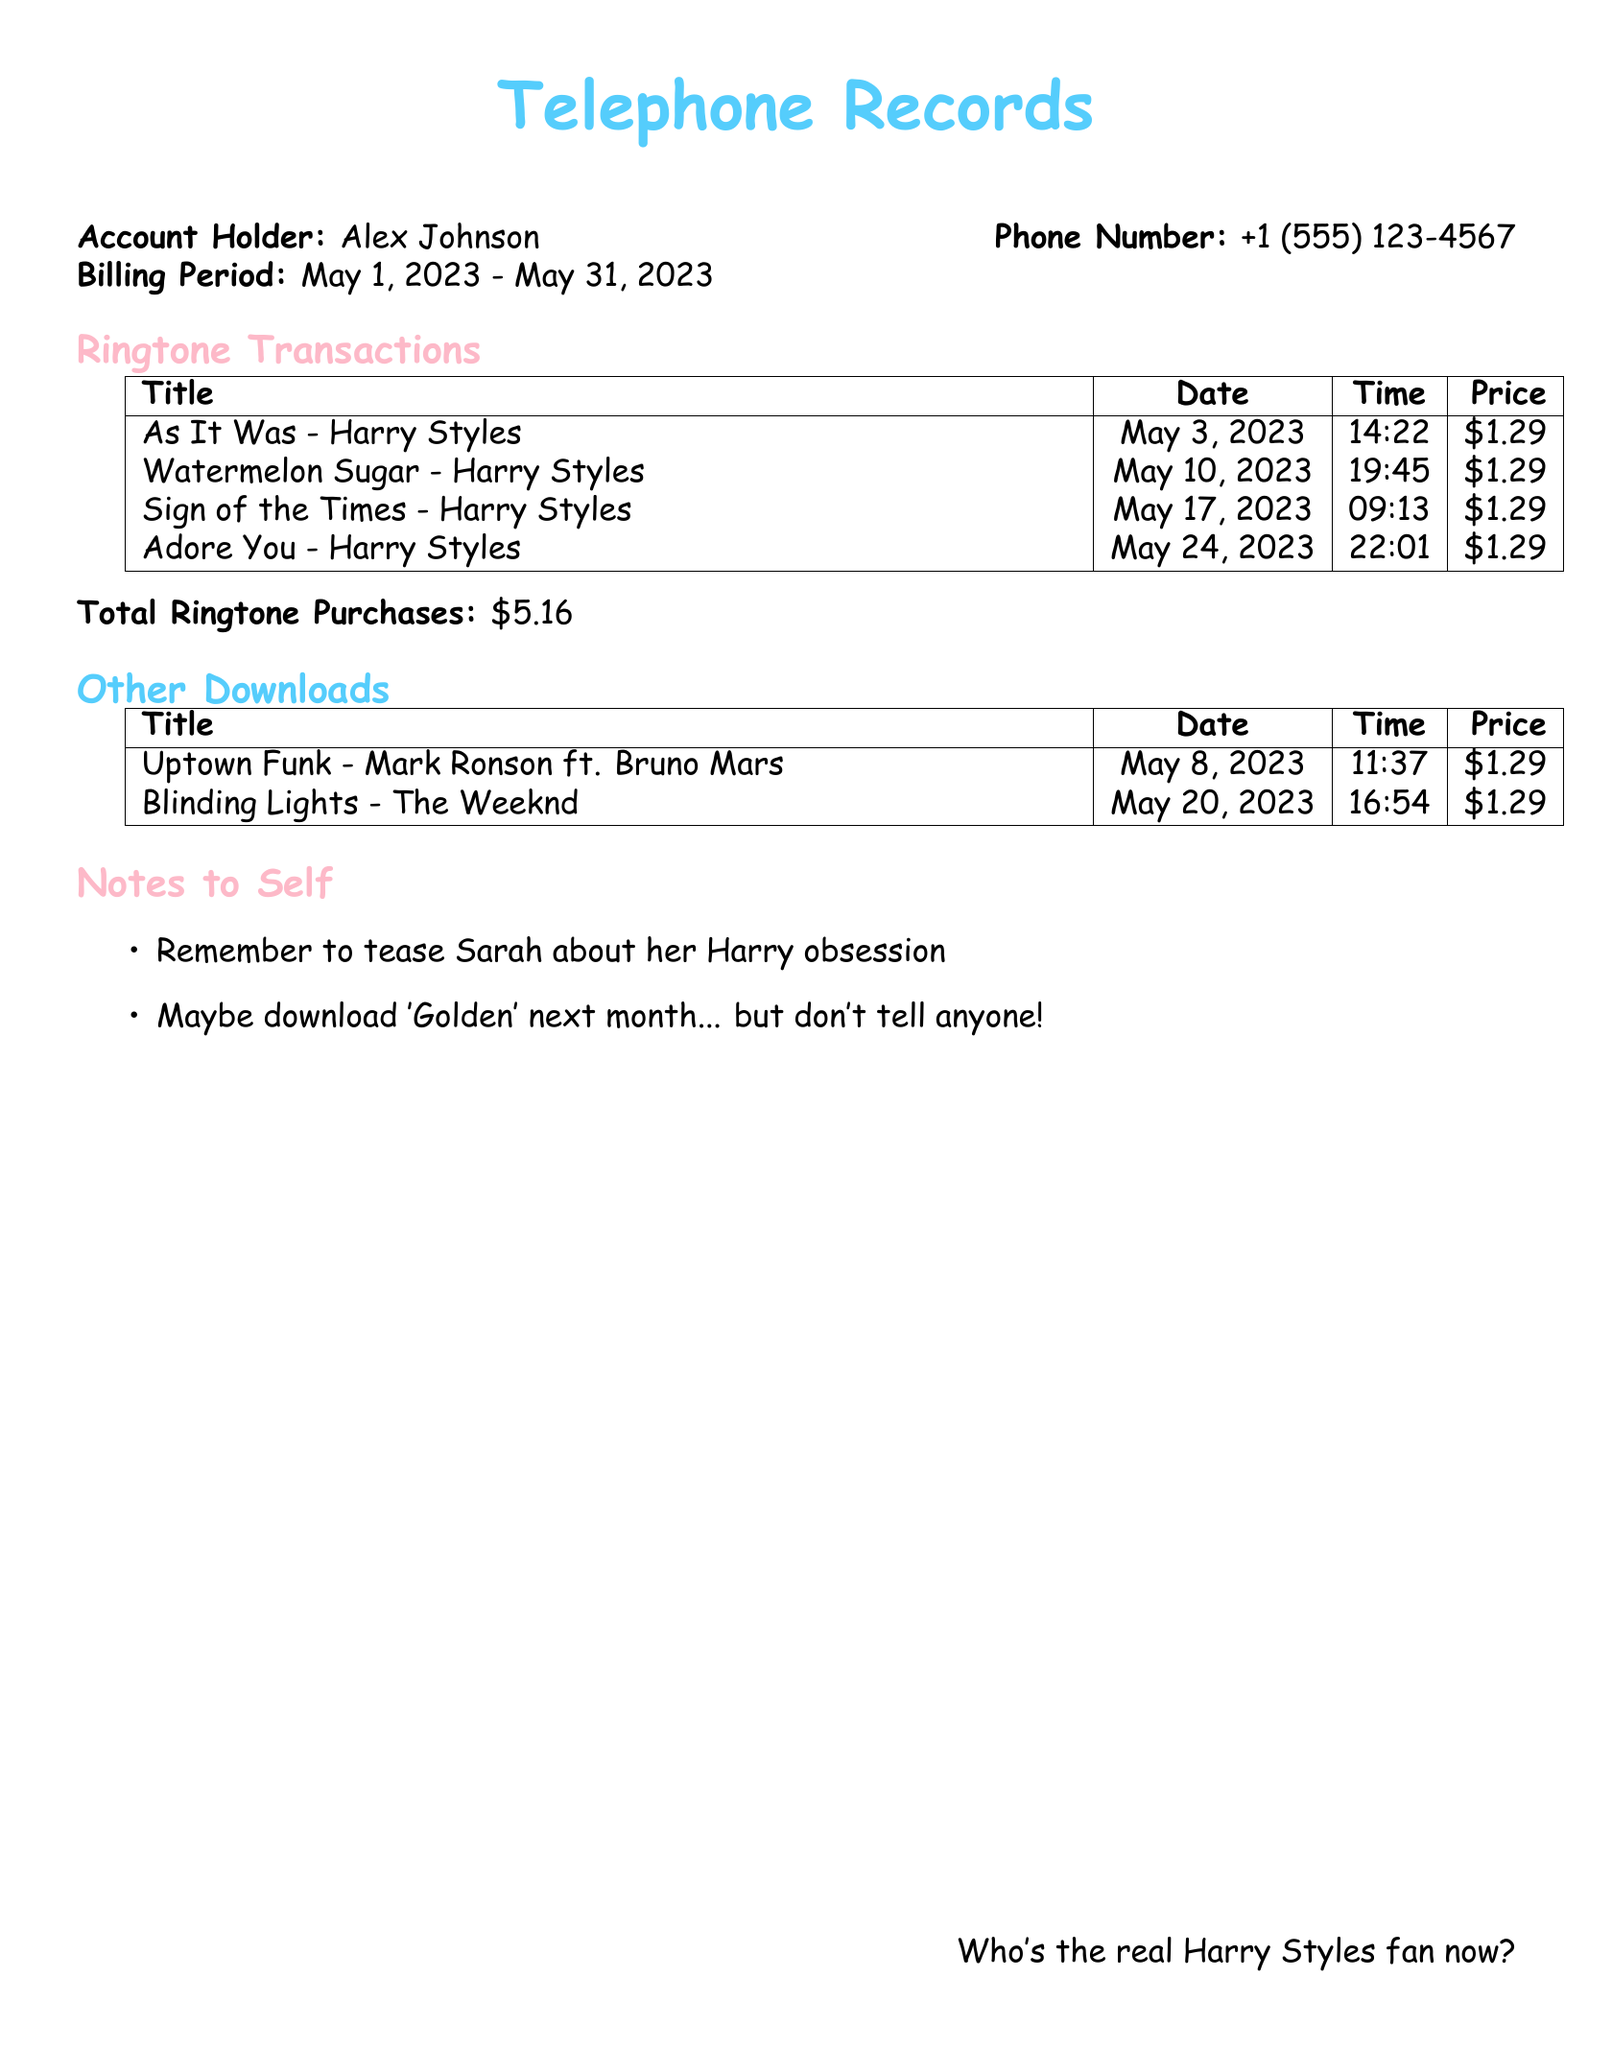what is the first Harry Styles ringtone purchased? The first Harry Styles ringtone listed in the document is "As It Was," purchased on May 3, 2023.
Answer: As It Was how much did "Watermelon Sugar" cost? The cost for "Watermelon Sugar" is shown in the transactions table as $1.29.
Answer: $1.29 how many Harry Styles ringtones were purchased in total? There are four Harry Styles ringtones listed in the transactions, so the total is 4.
Answer: 4 what is the total amount spent on all ringtone purchases? The total amount for ringtone purchases listed is $5.16.
Answer: $5.16 when was "Adore You" downloaded? "Adore You" was downloaded on May 24, 2023, according to the transaction details.
Answer: May 24, 2023 what is the most expensive ringtone listed? All ringtones listed are priced equally at $1.29, making none more expensive than the others.
Answer: None how many transactions are listed under "Other Downloads"? There are two transactions listed under "Other Downloads" in the document.
Answer: 2 what date was the last Harry Styles ringtone downloaded? The last Harry Styles ringtone was downloaded on May 24, 2023, as noted in the transaction table.
Answer: May 24, 2023 who is the account holder? The account holder's name is mentioned in the document as Alex Johnson.
Answer: Alex Johnson 